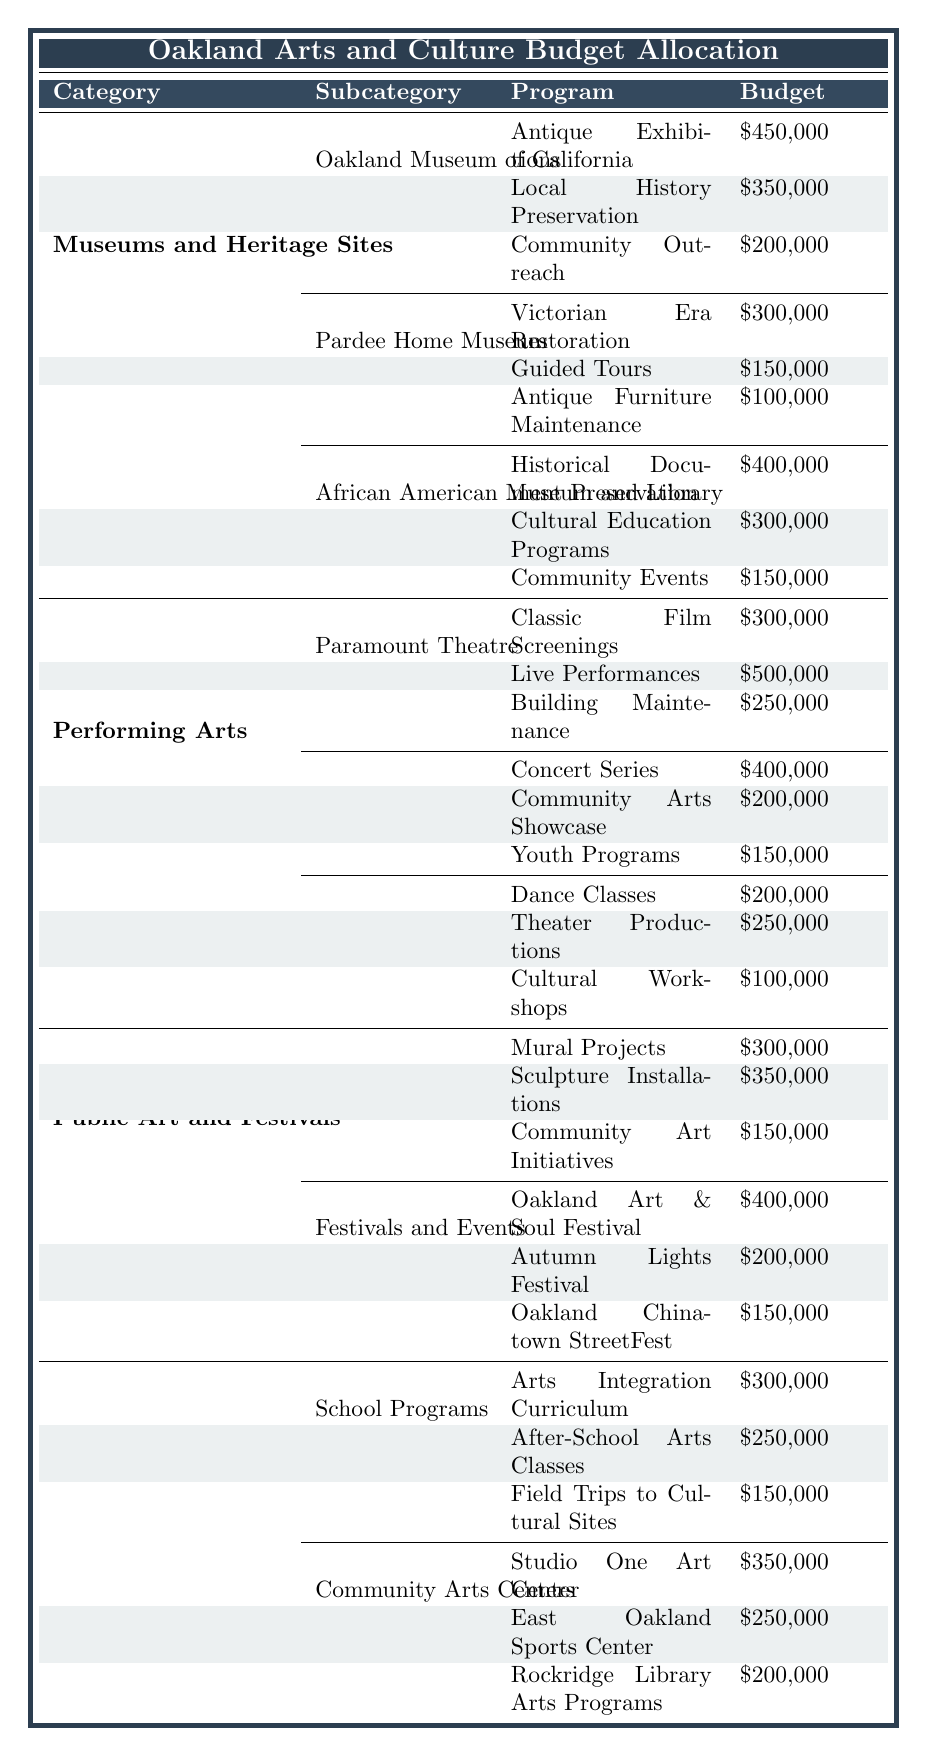What is the total budget allocated for Museums and Heritage Sites? According to the table, the total budget for Museums and Heritage Sites is explicitly listed, and it shows as $3,500,000.
Answer: $3,500,000 Which program in the Oakland Museum of California has the highest budget? In the table under the Oakland Museum of California, the program with the highest budget is Antique Exhibitions, which has a budget of $450,000.
Answer: Antique Exhibitions What is the combined budget allocation for the operating costs of the Paramount Theatre and Fox Theater? The total budget for the Paramount Theatre is $1,200,000 and for the Fox Theater it is $1,000,000. Adding these two amounts together gives: $1,200,000 + $1,000,000 = $2,200,000.
Answer: $2,200,000 Does Pardee Home Museum allocate more budget for Guided Tours than for Antique Furniture Maintenance? Yes, the budget allocated for Guided Tours at Pardee Home Museum is $150,000, while the budget for Antique Furniture Maintenance is $100,000. Since $150,000 is greater than $100,000, the statement is true.
Answer: Yes What is the total budget for Public Art and Festivals? The total budget for Public Art and Festivals listed in the table is $1,700,000.
Answer: $1,700,000 Calculate the total budget for all programs under the African American Museum and Library. The programs under the African American Museum and Library have the following budgets: Historical Document Preservation ($400,000), Cultural Education Programs ($300,000), and Community Events ($150,000). Adding these together gives: $400,000 + $300,000 + $150,000 = $850,000.
Answer: $850,000 Which category received the least budget allocation? The table presents four categories with their total budgets. By comparing them, it shows that Arts Education and Outreach has a total budget of $1,500,000, which is the least among the provided categories.
Answer: Arts Education and Outreach Is the budget for School Programs greater than the combined budget of Community Arts Centers? The budget for School Programs is listed as $700,000, while the total allocation for Community Arts Centers is $800,000. Since $700,000 is not greater than $800,000, this statement is false.
Answer: No What is the total budget for arts education programs from both School Programs and Community Arts Centers? The budget for School Programs totals $700,000 and for Community Arts Centers, it totals $800,000. Adding these two amounts yields: $700,000 + $800,000 = $1,500,000.
Answer: $1,500,000 Which subcategory under Public Art and Festivals has the highest individual program budget? In the Public Art and Festivals category, the Festivals and Events subcategory contains the Oakland Art & Soul Festival, which has a budget of $400,000. This is the highest among the individual program budgets listed under Public Art and Festivals.
Answer: Oakland Art & Soul Festival 